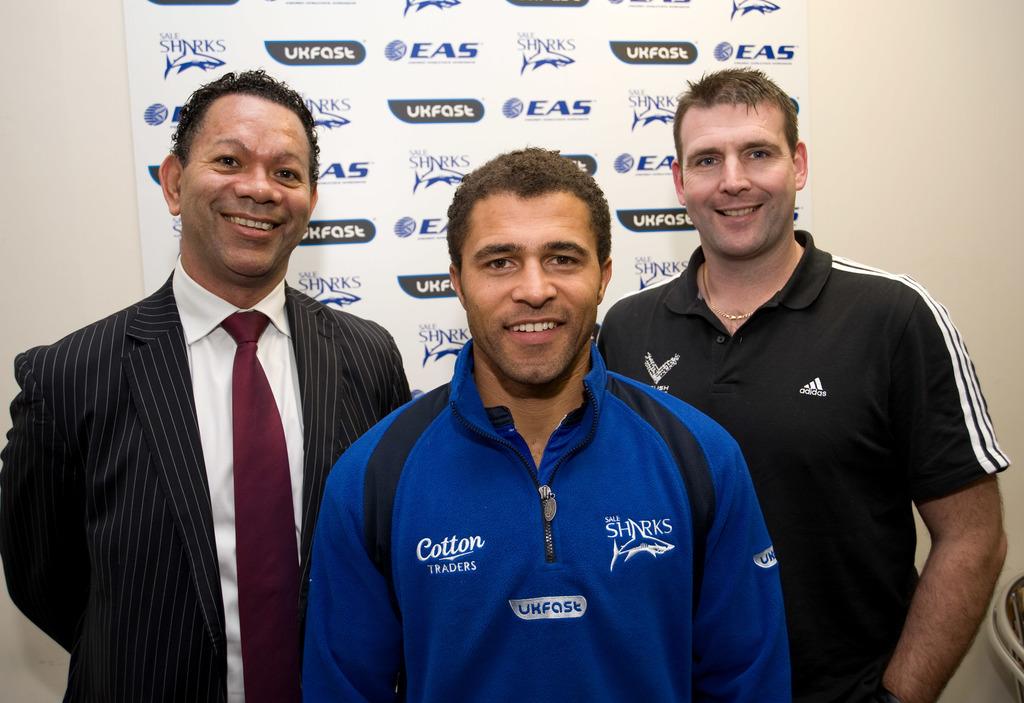Who is one of the sponsors on the backdrop?
Keep it short and to the point. Eas. What clothing brand is worn by the guy on the right?>?
Offer a very short reply. Adidas. 